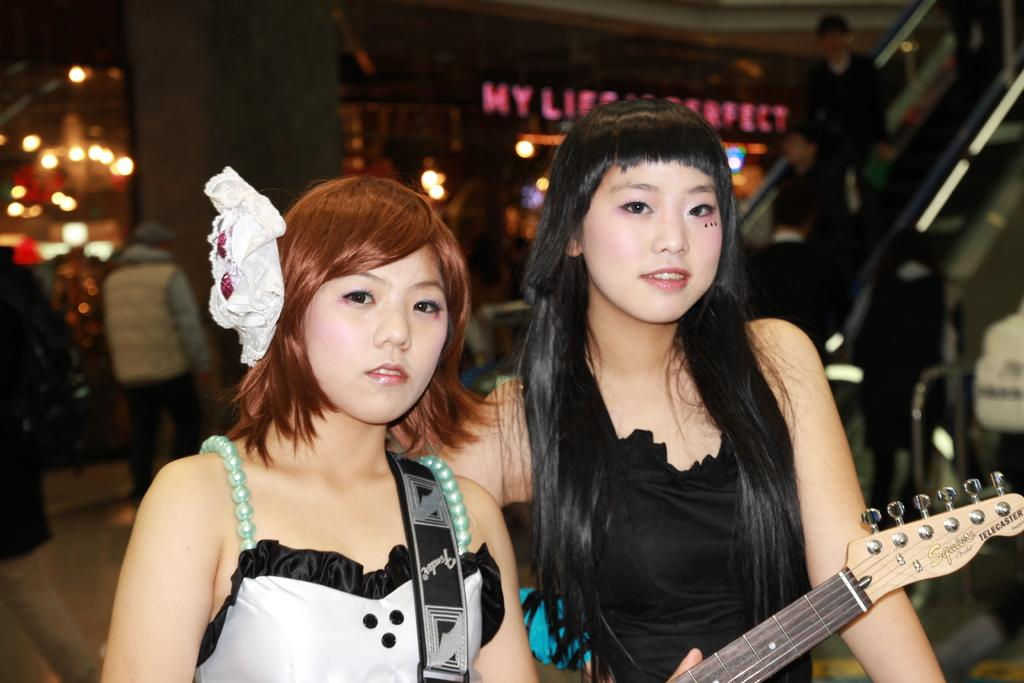What is the woman in the image wearing? There is a woman wearing a white dress in the image. What is the woman holding in the image? The woman is holding a guitar. Is there anyone else in the image with the woman holding the guitar? Yes, there is another woman standing beside her. Can you describe the group of people behind the women? There is a group of people behind the women, but their specific characteristics are not mentioned in the provided facts. What type of toothpaste is the woman using in the image? There is no toothpaste present in the image; the woman is holding a guitar. What kind of rod can be seen in the image? There is no rod present in the image. 